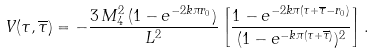Convert formula to latex. <formula><loc_0><loc_0><loc_500><loc_500>V ( \tau , \overline { \tau } ) = - \frac { 3 \, M _ { 4 } ^ { 2 } \, ( 1 - e ^ { - 2 k \pi r _ { 0 } } ) } { L ^ { 2 } } \left [ \frac { 1 - e ^ { - 2 k \pi ( \tau + \overline { \tau } - r _ { 0 } ) } } { ( 1 - e ^ { - k \pi ( \tau + \overline { \tau } ) } ) ^ { 2 } } \right ] .</formula> 